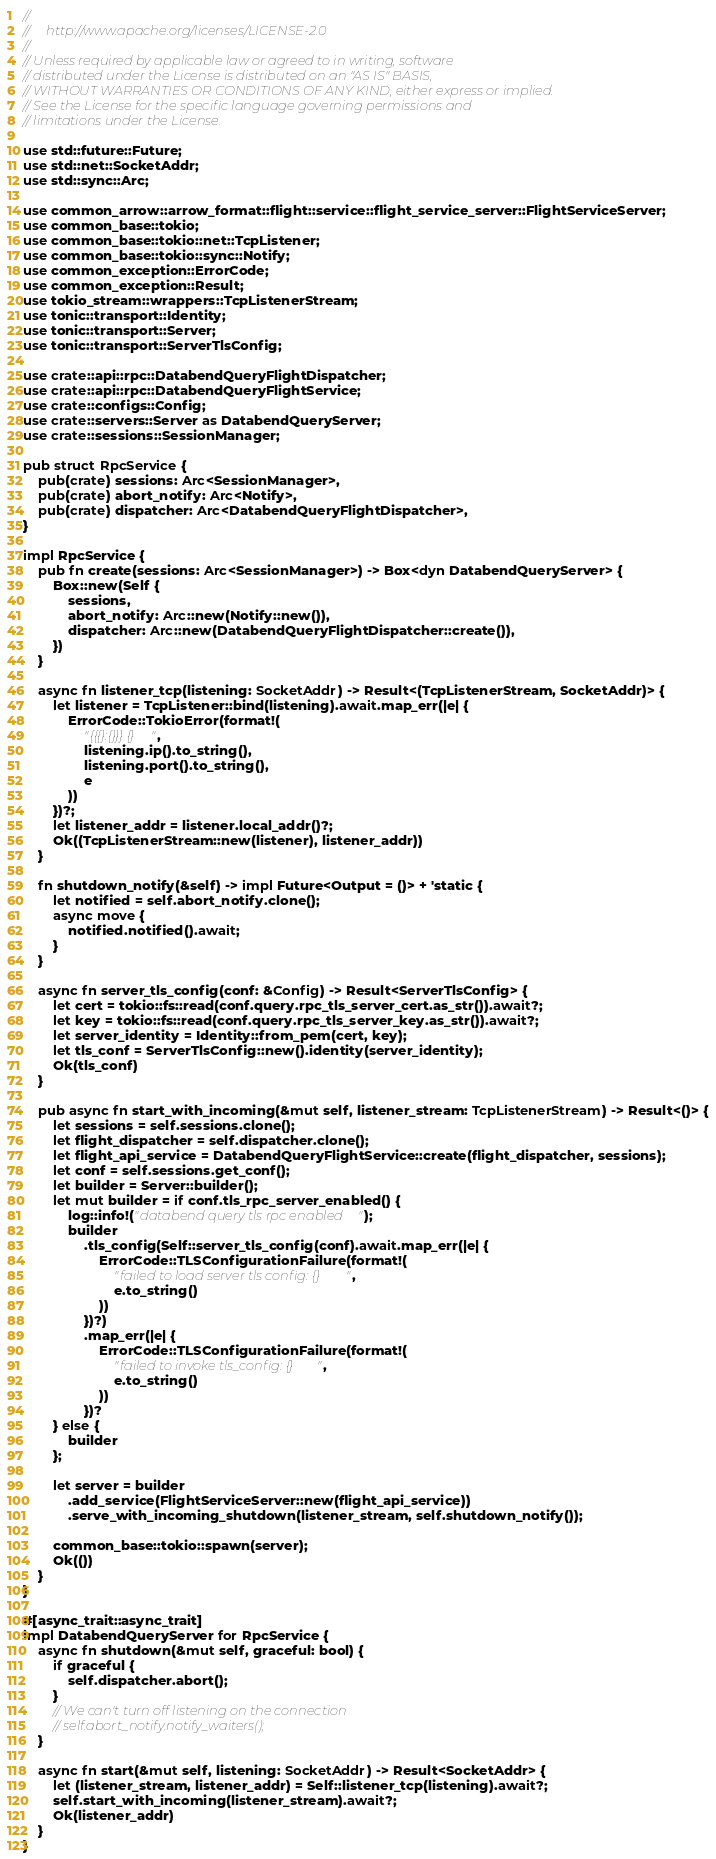Convert code to text. <code><loc_0><loc_0><loc_500><loc_500><_Rust_>//
//     http://www.apache.org/licenses/LICENSE-2.0
//
// Unless required by applicable law or agreed to in writing, software
// distributed under the License is distributed on an "AS IS" BASIS,
// WITHOUT WARRANTIES OR CONDITIONS OF ANY KIND, either express or implied.
// See the License for the specific language governing permissions and
// limitations under the License.

use std::future::Future;
use std::net::SocketAddr;
use std::sync::Arc;

use common_arrow::arrow_format::flight::service::flight_service_server::FlightServiceServer;
use common_base::tokio;
use common_base::tokio::net::TcpListener;
use common_base::tokio::sync::Notify;
use common_exception::ErrorCode;
use common_exception::Result;
use tokio_stream::wrappers::TcpListenerStream;
use tonic::transport::Identity;
use tonic::transport::Server;
use tonic::transport::ServerTlsConfig;

use crate::api::rpc::DatabendQueryFlightDispatcher;
use crate::api::rpc::DatabendQueryFlightService;
use crate::configs::Config;
use crate::servers::Server as DatabendQueryServer;
use crate::sessions::SessionManager;

pub struct RpcService {
    pub(crate) sessions: Arc<SessionManager>,
    pub(crate) abort_notify: Arc<Notify>,
    pub(crate) dispatcher: Arc<DatabendQueryFlightDispatcher>,
}

impl RpcService {
    pub fn create(sessions: Arc<SessionManager>) -> Box<dyn DatabendQueryServer> {
        Box::new(Self {
            sessions,
            abort_notify: Arc::new(Notify::new()),
            dispatcher: Arc::new(DatabendQueryFlightDispatcher::create()),
        })
    }

    async fn listener_tcp(listening: SocketAddr) -> Result<(TcpListenerStream, SocketAddr)> {
        let listener = TcpListener::bind(listening).await.map_err(|e| {
            ErrorCode::TokioError(format!(
                "{{{}:{}}} {}",
                listening.ip().to_string(),
                listening.port().to_string(),
                e
            ))
        })?;
        let listener_addr = listener.local_addr()?;
        Ok((TcpListenerStream::new(listener), listener_addr))
    }

    fn shutdown_notify(&self) -> impl Future<Output = ()> + 'static {
        let notified = self.abort_notify.clone();
        async move {
            notified.notified().await;
        }
    }

    async fn server_tls_config(conf: &Config) -> Result<ServerTlsConfig> {
        let cert = tokio::fs::read(conf.query.rpc_tls_server_cert.as_str()).await?;
        let key = tokio::fs::read(conf.query.rpc_tls_server_key.as_str()).await?;
        let server_identity = Identity::from_pem(cert, key);
        let tls_conf = ServerTlsConfig::new().identity(server_identity);
        Ok(tls_conf)
    }

    pub async fn start_with_incoming(&mut self, listener_stream: TcpListenerStream) -> Result<()> {
        let sessions = self.sessions.clone();
        let flight_dispatcher = self.dispatcher.clone();
        let flight_api_service = DatabendQueryFlightService::create(flight_dispatcher, sessions);
        let conf = self.sessions.get_conf();
        let builder = Server::builder();
        let mut builder = if conf.tls_rpc_server_enabled() {
            log::info!("databend query tls rpc enabled");
            builder
                .tls_config(Self::server_tls_config(conf).await.map_err(|e| {
                    ErrorCode::TLSConfigurationFailure(format!(
                        "failed to load server tls config: {}",
                        e.to_string()
                    ))
                })?)
                .map_err(|e| {
                    ErrorCode::TLSConfigurationFailure(format!(
                        "failed to invoke tls_config: {}",
                        e.to_string()
                    ))
                })?
        } else {
            builder
        };

        let server = builder
            .add_service(FlightServiceServer::new(flight_api_service))
            .serve_with_incoming_shutdown(listener_stream, self.shutdown_notify());

        common_base::tokio::spawn(server);
        Ok(())
    }
}

#[async_trait::async_trait]
impl DatabendQueryServer for RpcService {
    async fn shutdown(&mut self, graceful: bool) {
        if graceful {
            self.dispatcher.abort();
        }
        // We can't turn off listening on the connection
        // self.abort_notify.notify_waiters();
    }

    async fn start(&mut self, listening: SocketAddr) -> Result<SocketAddr> {
        let (listener_stream, listener_addr) = Self::listener_tcp(listening).await?;
        self.start_with_incoming(listener_stream).await?;
        Ok(listener_addr)
    }
}
</code> 